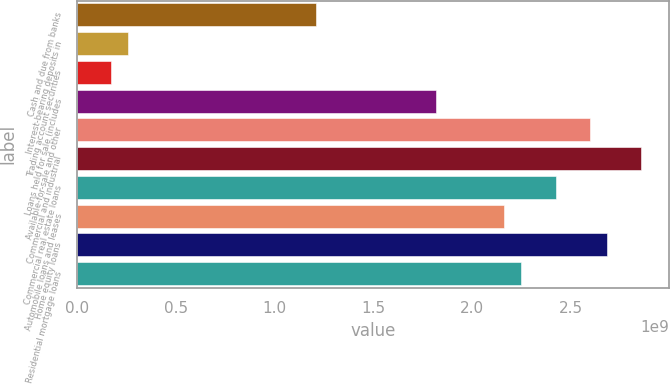<chart> <loc_0><loc_0><loc_500><loc_500><bar_chart><fcel>Cash and due from banks<fcel>Interest-bearing deposits in<fcel>Trading account securities<fcel>Loans held for sale (includes<fcel>Available-for-sale and other<fcel>Commercial and industrial<fcel>Commercial real estate loans<fcel>Automobile loans and leases<fcel>Home equity loans<fcel>Residential mortgage loans<nl><fcel>1.21181e+09<fcel>2.59681e+08<fcel>1.73124e+08<fcel>1.81772e+09<fcel>2.59674e+09<fcel>2.85641e+09<fcel>2.42362e+09<fcel>2.16395e+09<fcel>2.68329e+09<fcel>2.25051e+09<nl></chart> 